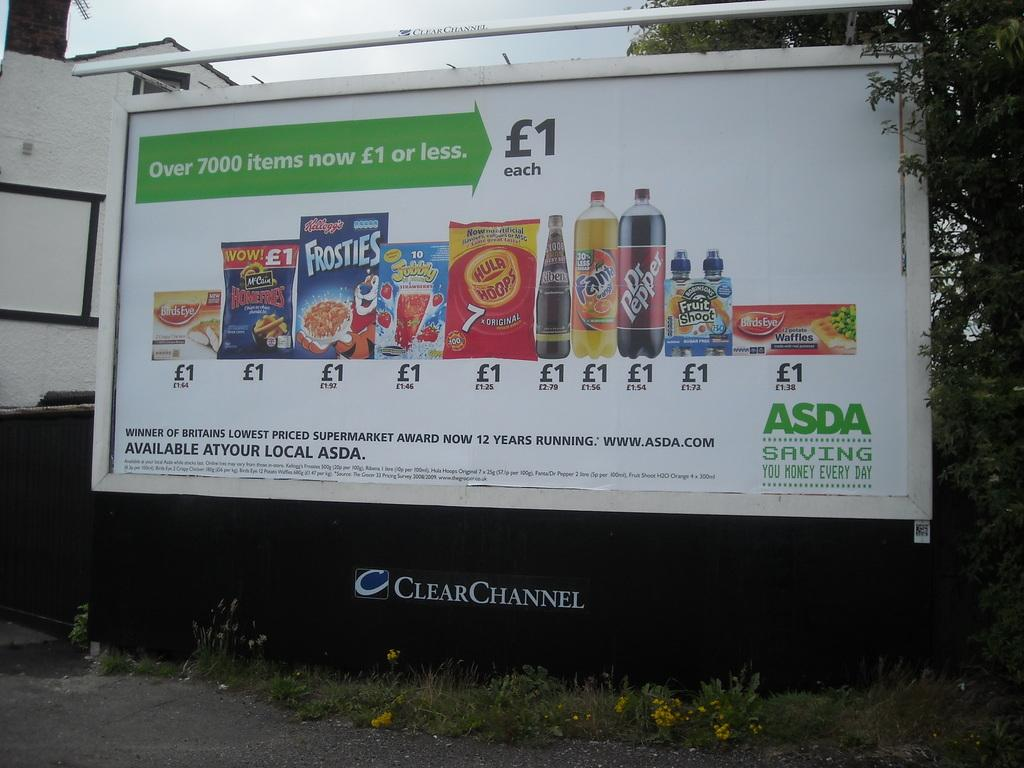Provide a one-sentence caption for the provided image. a billboard for ASDA displaying common name brand groceries. 